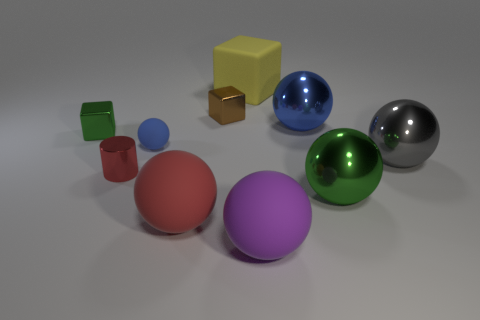There is a large thing that is to the left of the tiny brown metal thing; does it have the same shape as the blue object that is to the left of the yellow cube?
Offer a very short reply. Yes. There is a brown block; does it have the same size as the green object that is right of the large blue metal object?
Keep it short and to the point. No. How many other objects are there of the same material as the big purple object?
Keep it short and to the point. 3. Is there anything else that is the same shape as the tiny red metallic thing?
Give a very brief answer. No. The rubber thing right of the large yellow rubber thing that is to the left of the blue ball to the right of the red sphere is what color?
Ensure brevity in your answer.  Purple. What shape is the tiny thing that is both behind the large gray thing and on the left side of the tiny sphere?
Offer a very short reply. Cube. What is the color of the small shiny object on the right side of the tiny blue matte thing behind the gray object?
Provide a short and direct response. Brown. What is the shape of the green metallic thing to the right of the tiny shiny block left of the big sphere to the left of the purple matte object?
Your answer should be compact. Sphere. How big is the ball that is both in front of the red metallic thing and left of the tiny brown object?
Your response must be concise. Large. What number of other matte spheres are the same color as the tiny rubber ball?
Your answer should be very brief. 0. 